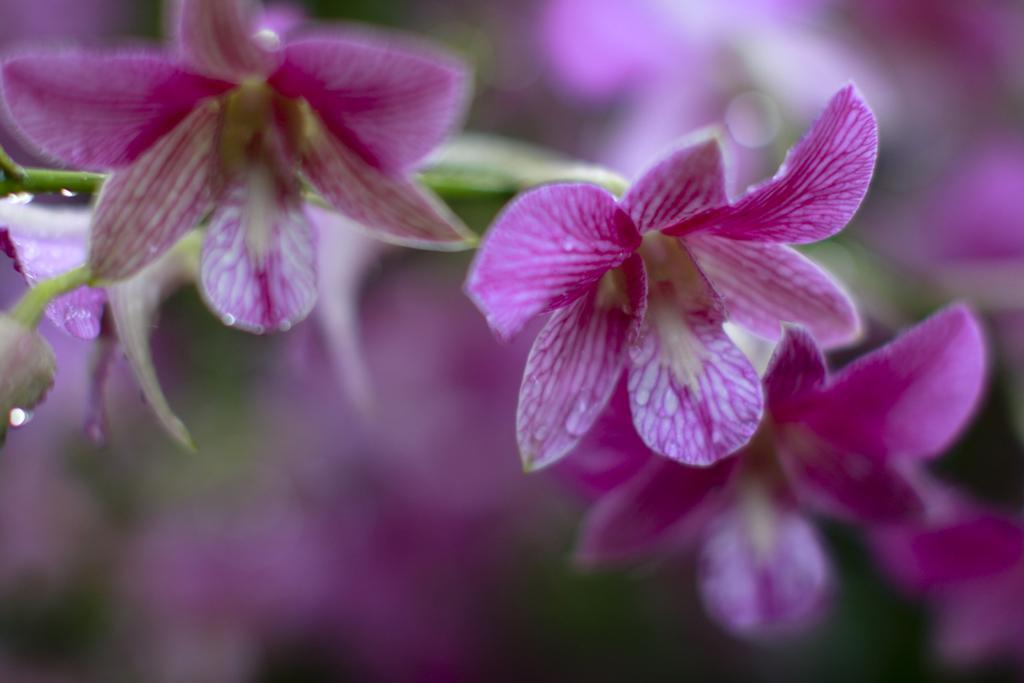Can you describe this image briefly? In this picture we can see purple orchids. 